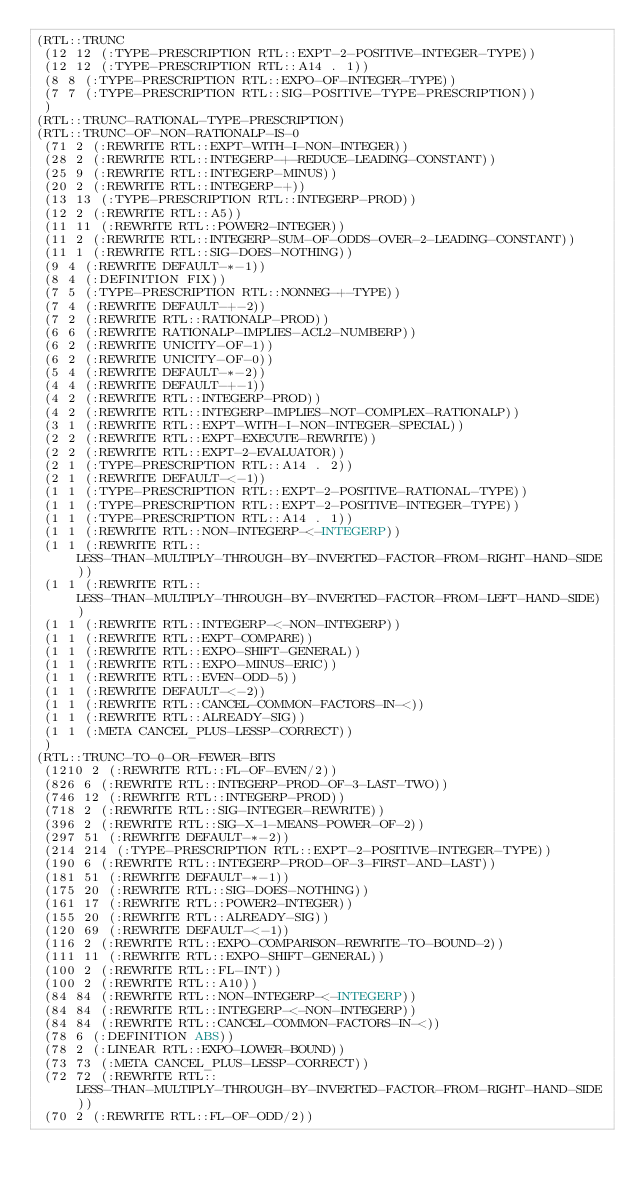<code> <loc_0><loc_0><loc_500><loc_500><_Lisp_>(RTL::TRUNC
 (12 12 (:TYPE-PRESCRIPTION RTL::EXPT-2-POSITIVE-INTEGER-TYPE))
 (12 12 (:TYPE-PRESCRIPTION RTL::A14 . 1))
 (8 8 (:TYPE-PRESCRIPTION RTL::EXPO-OF-INTEGER-TYPE))
 (7 7 (:TYPE-PRESCRIPTION RTL::SIG-POSITIVE-TYPE-PRESCRIPTION))
 )
(RTL::TRUNC-RATIONAL-TYPE-PRESCRIPTION)
(RTL::TRUNC-OF-NON-RATIONALP-IS-0
 (71 2 (:REWRITE RTL::EXPT-WITH-I-NON-INTEGER))
 (28 2 (:REWRITE RTL::INTEGERP-+-REDUCE-LEADING-CONSTANT))
 (25 9 (:REWRITE RTL::INTEGERP-MINUS))
 (20 2 (:REWRITE RTL::INTEGERP-+))
 (13 13 (:TYPE-PRESCRIPTION RTL::INTEGERP-PROD))
 (12 2 (:REWRITE RTL::A5))
 (11 11 (:REWRITE RTL::POWER2-INTEGER))
 (11 2 (:REWRITE RTL::INTEGERP-SUM-OF-ODDS-OVER-2-LEADING-CONSTANT))
 (11 1 (:REWRITE RTL::SIG-DOES-NOTHING))
 (9 4 (:REWRITE DEFAULT-*-1))
 (8 4 (:DEFINITION FIX))
 (7 5 (:TYPE-PRESCRIPTION RTL::NONNEG-+-TYPE))
 (7 4 (:REWRITE DEFAULT-+-2))
 (7 2 (:REWRITE RTL::RATIONALP-PROD))
 (6 6 (:REWRITE RATIONALP-IMPLIES-ACL2-NUMBERP))
 (6 2 (:REWRITE UNICITY-OF-1))
 (6 2 (:REWRITE UNICITY-OF-0))
 (5 4 (:REWRITE DEFAULT-*-2))
 (4 4 (:REWRITE DEFAULT-+-1))
 (4 2 (:REWRITE RTL::INTEGERP-PROD))
 (4 2 (:REWRITE RTL::INTEGERP-IMPLIES-NOT-COMPLEX-RATIONALP))
 (3 1 (:REWRITE RTL::EXPT-WITH-I-NON-INTEGER-SPECIAL))
 (2 2 (:REWRITE RTL::EXPT-EXECUTE-REWRITE))
 (2 2 (:REWRITE RTL::EXPT-2-EVALUATOR))
 (2 1 (:TYPE-PRESCRIPTION RTL::A14 . 2))
 (2 1 (:REWRITE DEFAULT-<-1))
 (1 1 (:TYPE-PRESCRIPTION RTL::EXPT-2-POSITIVE-RATIONAL-TYPE))
 (1 1 (:TYPE-PRESCRIPTION RTL::EXPT-2-POSITIVE-INTEGER-TYPE))
 (1 1 (:TYPE-PRESCRIPTION RTL::A14 . 1))
 (1 1 (:REWRITE RTL::NON-INTEGERP-<-INTEGERP))
 (1 1 (:REWRITE RTL::LESS-THAN-MULTIPLY-THROUGH-BY-INVERTED-FACTOR-FROM-RIGHT-HAND-SIDE))
 (1 1 (:REWRITE RTL::LESS-THAN-MULTIPLY-THROUGH-BY-INVERTED-FACTOR-FROM-LEFT-HAND-SIDE))
 (1 1 (:REWRITE RTL::INTEGERP-<-NON-INTEGERP))
 (1 1 (:REWRITE RTL::EXPT-COMPARE))
 (1 1 (:REWRITE RTL::EXPO-SHIFT-GENERAL))
 (1 1 (:REWRITE RTL::EXPO-MINUS-ERIC))
 (1 1 (:REWRITE RTL::EVEN-ODD-5))
 (1 1 (:REWRITE DEFAULT-<-2))
 (1 1 (:REWRITE RTL::CANCEL-COMMON-FACTORS-IN-<))
 (1 1 (:REWRITE RTL::ALREADY-SIG))
 (1 1 (:META CANCEL_PLUS-LESSP-CORRECT))
 )
(RTL::TRUNC-TO-0-OR-FEWER-BITS
 (1210 2 (:REWRITE RTL::FL-OF-EVEN/2))
 (826 6 (:REWRITE RTL::INTEGERP-PROD-OF-3-LAST-TWO))
 (746 12 (:REWRITE RTL::INTEGERP-PROD))
 (718 2 (:REWRITE RTL::SIG-INTEGER-REWRITE))
 (396 2 (:REWRITE RTL::SIG-X-1-MEANS-POWER-OF-2))
 (297 51 (:REWRITE DEFAULT-*-2))
 (214 214 (:TYPE-PRESCRIPTION RTL::EXPT-2-POSITIVE-INTEGER-TYPE))
 (190 6 (:REWRITE RTL::INTEGERP-PROD-OF-3-FIRST-AND-LAST))
 (181 51 (:REWRITE DEFAULT-*-1))
 (175 20 (:REWRITE RTL::SIG-DOES-NOTHING))
 (161 17 (:REWRITE RTL::POWER2-INTEGER))
 (155 20 (:REWRITE RTL::ALREADY-SIG))
 (120 69 (:REWRITE DEFAULT-<-1))
 (116 2 (:REWRITE RTL::EXPO-COMPARISON-REWRITE-TO-BOUND-2))
 (111 11 (:REWRITE RTL::EXPO-SHIFT-GENERAL))
 (100 2 (:REWRITE RTL::FL-INT))
 (100 2 (:REWRITE RTL::A10))
 (84 84 (:REWRITE RTL::NON-INTEGERP-<-INTEGERP))
 (84 84 (:REWRITE RTL::INTEGERP-<-NON-INTEGERP))
 (84 84 (:REWRITE RTL::CANCEL-COMMON-FACTORS-IN-<))
 (78 6 (:DEFINITION ABS))
 (78 2 (:LINEAR RTL::EXPO-LOWER-BOUND))
 (73 73 (:META CANCEL_PLUS-LESSP-CORRECT))
 (72 72 (:REWRITE RTL::LESS-THAN-MULTIPLY-THROUGH-BY-INVERTED-FACTOR-FROM-RIGHT-HAND-SIDE))
 (70 2 (:REWRITE RTL::FL-OF-ODD/2))</code> 